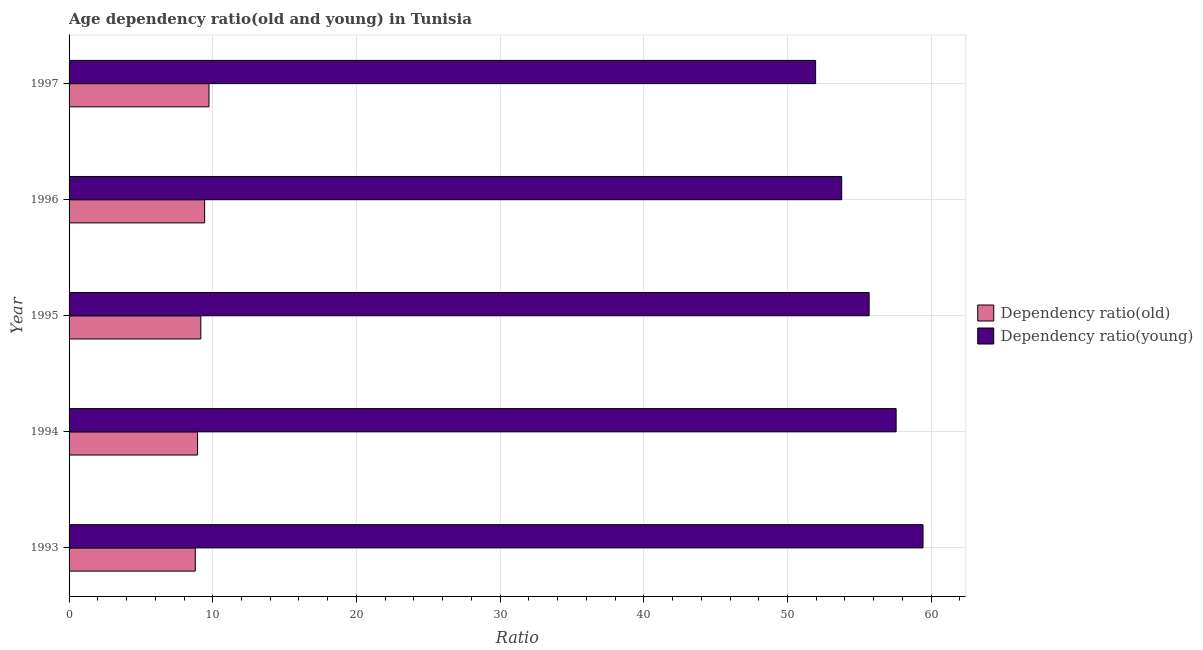How many different coloured bars are there?
Provide a succinct answer. 2. How many groups of bars are there?
Offer a very short reply. 5. Are the number of bars per tick equal to the number of legend labels?
Your response must be concise. Yes. Are the number of bars on each tick of the Y-axis equal?
Your answer should be very brief. Yes. How many bars are there on the 1st tick from the top?
Make the answer very short. 2. How many bars are there on the 3rd tick from the bottom?
Your response must be concise. 2. What is the label of the 2nd group of bars from the top?
Keep it short and to the point. 1996. What is the age dependency ratio(old) in 1997?
Your answer should be compact. 9.74. Across all years, what is the maximum age dependency ratio(young)?
Offer a terse response. 59.43. Across all years, what is the minimum age dependency ratio(old)?
Make the answer very short. 8.78. In which year was the age dependency ratio(young) maximum?
Your response must be concise. 1993. In which year was the age dependency ratio(young) minimum?
Your answer should be very brief. 1997. What is the total age dependency ratio(old) in the graph?
Your answer should be very brief. 46.07. What is the difference between the age dependency ratio(old) in 1993 and that in 1994?
Provide a succinct answer. -0.16. What is the difference between the age dependency ratio(young) in 1994 and the age dependency ratio(old) in 1997?
Give a very brief answer. 47.82. What is the average age dependency ratio(young) per year?
Make the answer very short. 55.68. In the year 1994, what is the difference between the age dependency ratio(young) and age dependency ratio(old)?
Your response must be concise. 48.62. What is the ratio of the age dependency ratio(old) in 1994 to that in 1996?
Give a very brief answer. 0.95. What is the difference between the highest and the second highest age dependency ratio(old)?
Provide a succinct answer. 0.3. What is the difference between the highest and the lowest age dependency ratio(young)?
Make the answer very short. 7.47. In how many years, is the age dependency ratio(old) greater than the average age dependency ratio(old) taken over all years?
Provide a succinct answer. 2. Is the sum of the age dependency ratio(young) in 1996 and 1997 greater than the maximum age dependency ratio(old) across all years?
Your response must be concise. Yes. What does the 1st bar from the top in 1993 represents?
Your answer should be very brief. Dependency ratio(young). What does the 1st bar from the bottom in 1997 represents?
Your response must be concise. Dependency ratio(old). How many bars are there?
Give a very brief answer. 10. How many years are there in the graph?
Provide a short and direct response. 5. What is the difference between two consecutive major ticks on the X-axis?
Offer a terse response. 10. Are the values on the major ticks of X-axis written in scientific E-notation?
Provide a short and direct response. No. Does the graph contain any zero values?
Make the answer very short. No. Does the graph contain grids?
Your response must be concise. Yes. Where does the legend appear in the graph?
Your answer should be very brief. Center right. How many legend labels are there?
Keep it short and to the point. 2. How are the legend labels stacked?
Provide a succinct answer. Vertical. What is the title of the graph?
Give a very brief answer. Age dependency ratio(old and young) in Tunisia. Does "current US$" appear as one of the legend labels in the graph?
Provide a short and direct response. No. What is the label or title of the X-axis?
Provide a short and direct response. Ratio. What is the Ratio in Dependency ratio(old) in 1993?
Your answer should be compact. 8.78. What is the Ratio in Dependency ratio(young) in 1993?
Ensure brevity in your answer.  59.43. What is the Ratio in Dependency ratio(old) in 1994?
Ensure brevity in your answer.  8.94. What is the Ratio of Dependency ratio(young) in 1994?
Offer a terse response. 57.56. What is the Ratio in Dependency ratio(old) in 1995?
Provide a short and direct response. 9.17. What is the Ratio in Dependency ratio(young) in 1995?
Give a very brief answer. 55.68. What is the Ratio of Dependency ratio(old) in 1996?
Your answer should be compact. 9.44. What is the Ratio in Dependency ratio(young) in 1996?
Provide a succinct answer. 53.77. What is the Ratio of Dependency ratio(old) in 1997?
Ensure brevity in your answer.  9.74. What is the Ratio of Dependency ratio(young) in 1997?
Give a very brief answer. 51.96. Across all years, what is the maximum Ratio in Dependency ratio(old)?
Make the answer very short. 9.74. Across all years, what is the maximum Ratio of Dependency ratio(young)?
Give a very brief answer. 59.43. Across all years, what is the minimum Ratio of Dependency ratio(old)?
Provide a short and direct response. 8.78. Across all years, what is the minimum Ratio in Dependency ratio(young)?
Keep it short and to the point. 51.96. What is the total Ratio in Dependency ratio(old) in the graph?
Provide a succinct answer. 46.07. What is the total Ratio in Dependency ratio(young) in the graph?
Your answer should be very brief. 278.4. What is the difference between the Ratio in Dependency ratio(old) in 1993 and that in 1994?
Offer a terse response. -0.16. What is the difference between the Ratio in Dependency ratio(young) in 1993 and that in 1994?
Ensure brevity in your answer.  1.87. What is the difference between the Ratio in Dependency ratio(old) in 1993 and that in 1995?
Your answer should be compact. -0.39. What is the difference between the Ratio in Dependency ratio(young) in 1993 and that in 1995?
Keep it short and to the point. 3.75. What is the difference between the Ratio in Dependency ratio(old) in 1993 and that in 1996?
Ensure brevity in your answer.  -0.65. What is the difference between the Ratio of Dependency ratio(young) in 1993 and that in 1996?
Keep it short and to the point. 5.66. What is the difference between the Ratio of Dependency ratio(old) in 1993 and that in 1997?
Make the answer very short. -0.95. What is the difference between the Ratio of Dependency ratio(young) in 1993 and that in 1997?
Your answer should be very brief. 7.47. What is the difference between the Ratio in Dependency ratio(old) in 1994 and that in 1995?
Offer a very short reply. -0.23. What is the difference between the Ratio in Dependency ratio(young) in 1994 and that in 1995?
Give a very brief answer. 1.88. What is the difference between the Ratio in Dependency ratio(old) in 1994 and that in 1996?
Your answer should be very brief. -0.49. What is the difference between the Ratio in Dependency ratio(young) in 1994 and that in 1996?
Your answer should be very brief. 3.79. What is the difference between the Ratio of Dependency ratio(old) in 1994 and that in 1997?
Give a very brief answer. -0.79. What is the difference between the Ratio in Dependency ratio(young) in 1994 and that in 1997?
Provide a short and direct response. 5.6. What is the difference between the Ratio in Dependency ratio(old) in 1995 and that in 1996?
Keep it short and to the point. -0.27. What is the difference between the Ratio of Dependency ratio(young) in 1995 and that in 1996?
Ensure brevity in your answer.  1.91. What is the difference between the Ratio of Dependency ratio(old) in 1995 and that in 1997?
Keep it short and to the point. -0.57. What is the difference between the Ratio of Dependency ratio(young) in 1995 and that in 1997?
Provide a succinct answer. 3.72. What is the difference between the Ratio of Dependency ratio(old) in 1996 and that in 1997?
Your answer should be compact. -0.3. What is the difference between the Ratio in Dependency ratio(young) in 1996 and that in 1997?
Ensure brevity in your answer.  1.81. What is the difference between the Ratio in Dependency ratio(old) in 1993 and the Ratio in Dependency ratio(young) in 1994?
Keep it short and to the point. -48.78. What is the difference between the Ratio in Dependency ratio(old) in 1993 and the Ratio in Dependency ratio(young) in 1995?
Your answer should be very brief. -46.9. What is the difference between the Ratio of Dependency ratio(old) in 1993 and the Ratio of Dependency ratio(young) in 1996?
Your answer should be very brief. -44.99. What is the difference between the Ratio in Dependency ratio(old) in 1993 and the Ratio in Dependency ratio(young) in 1997?
Your answer should be very brief. -43.17. What is the difference between the Ratio of Dependency ratio(old) in 1994 and the Ratio of Dependency ratio(young) in 1995?
Give a very brief answer. -46.74. What is the difference between the Ratio in Dependency ratio(old) in 1994 and the Ratio in Dependency ratio(young) in 1996?
Your response must be concise. -44.83. What is the difference between the Ratio in Dependency ratio(old) in 1994 and the Ratio in Dependency ratio(young) in 1997?
Give a very brief answer. -43.01. What is the difference between the Ratio in Dependency ratio(old) in 1995 and the Ratio in Dependency ratio(young) in 1996?
Keep it short and to the point. -44.6. What is the difference between the Ratio of Dependency ratio(old) in 1995 and the Ratio of Dependency ratio(young) in 1997?
Keep it short and to the point. -42.79. What is the difference between the Ratio in Dependency ratio(old) in 1996 and the Ratio in Dependency ratio(young) in 1997?
Ensure brevity in your answer.  -42.52. What is the average Ratio in Dependency ratio(old) per year?
Provide a succinct answer. 9.21. What is the average Ratio of Dependency ratio(young) per year?
Offer a very short reply. 55.68. In the year 1993, what is the difference between the Ratio in Dependency ratio(old) and Ratio in Dependency ratio(young)?
Your answer should be compact. -50.65. In the year 1994, what is the difference between the Ratio in Dependency ratio(old) and Ratio in Dependency ratio(young)?
Your answer should be compact. -48.62. In the year 1995, what is the difference between the Ratio in Dependency ratio(old) and Ratio in Dependency ratio(young)?
Offer a terse response. -46.51. In the year 1996, what is the difference between the Ratio in Dependency ratio(old) and Ratio in Dependency ratio(young)?
Provide a succinct answer. -44.33. In the year 1997, what is the difference between the Ratio of Dependency ratio(old) and Ratio of Dependency ratio(young)?
Your response must be concise. -42.22. What is the ratio of the Ratio of Dependency ratio(young) in 1993 to that in 1994?
Your answer should be compact. 1.03. What is the ratio of the Ratio of Dependency ratio(old) in 1993 to that in 1995?
Provide a succinct answer. 0.96. What is the ratio of the Ratio in Dependency ratio(young) in 1993 to that in 1995?
Keep it short and to the point. 1.07. What is the ratio of the Ratio of Dependency ratio(old) in 1993 to that in 1996?
Your answer should be compact. 0.93. What is the ratio of the Ratio in Dependency ratio(young) in 1993 to that in 1996?
Provide a short and direct response. 1.11. What is the ratio of the Ratio in Dependency ratio(old) in 1993 to that in 1997?
Offer a terse response. 0.9. What is the ratio of the Ratio in Dependency ratio(young) in 1993 to that in 1997?
Your answer should be compact. 1.14. What is the ratio of the Ratio of Dependency ratio(old) in 1994 to that in 1995?
Your response must be concise. 0.98. What is the ratio of the Ratio of Dependency ratio(young) in 1994 to that in 1995?
Ensure brevity in your answer.  1.03. What is the ratio of the Ratio in Dependency ratio(old) in 1994 to that in 1996?
Give a very brief answer. 0.95. What is the ratio of the Ratio in Dependency ratio(young) in 1994 to that in 1996?
Make the answer very short. 1.07. What is the ratio of the Ratio in Dependency ratio(old) in 1994 to that in 1997?
Offer a very short reply. 0.92. What is the ratio of the Ratio in Dependency ratio(young) in 1994 to that in 1997?
Your response must be concise. 1.11. What is the ratio of the Ratio of Dependency ratio(old) in 1995 to that in 1996?
Make the answer very short. 0.97. What is the ratio of the Ratio in Dependency ratio(young) in 1995 to that in 1996?
Make the answer very short. 1.04. What is the ratio of the Ratio of Dependency ratio(old) in 1995 to that in 1997?
Your response must be concise. 0.94. What is the ratio of the Ratio in Dependency ratio(young) in 1995 to that in 1997?
Make the answer very short. 1.07. What is the ratio of the Ratio in Dependency ratio(old) in 1996 to that in 1997?
Your answer should be compact. 0.97. What is the ratio of the Ratio of Dependency ratio(young) in 1996 to that in 1997?
Provide a succinct answer. 1.03. What is the difference between the highest and the second highest Ratio of Dependency ratio(old)?
Make the answer very short. 0.3. What is the difference between the highest and the second highest Ratio in Dependency ratio(young)?
Ensure brevity in your answer.  1.87. What is the difference between the highest and the lowest Ratio in Dependency ratio(old)?
Your answer should be compact. 0.95. What is the difference between the highest and the lowest Ratio in Dependency ratio(young)?
Give a very brief answer. 7.47. 